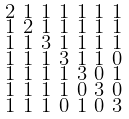<formula> <loc_0><loc_0><loc_500><loc_500>\begin{smallmatrix} 2 & 1 & 1 & 1 & 1 & 1 & 1 \\ 1 & 2 & 1 & 1 & 1 & 1 & 1 \\ 1 & 1 & 3 & 1 & 1 & 1 & 1 \\ 1 & 1 & 1 & 3 & 1 & 1 & 0 \\ 1 & 1 & 1 & 1 & 3 & 0 & 1 \\ 1 & 1 & 1 & 1 & 0 & 3 & 0 \\ 1 & 1 & 1 & 0 & 1 & 0 & 3 \end{smallmatrix}</formula> 